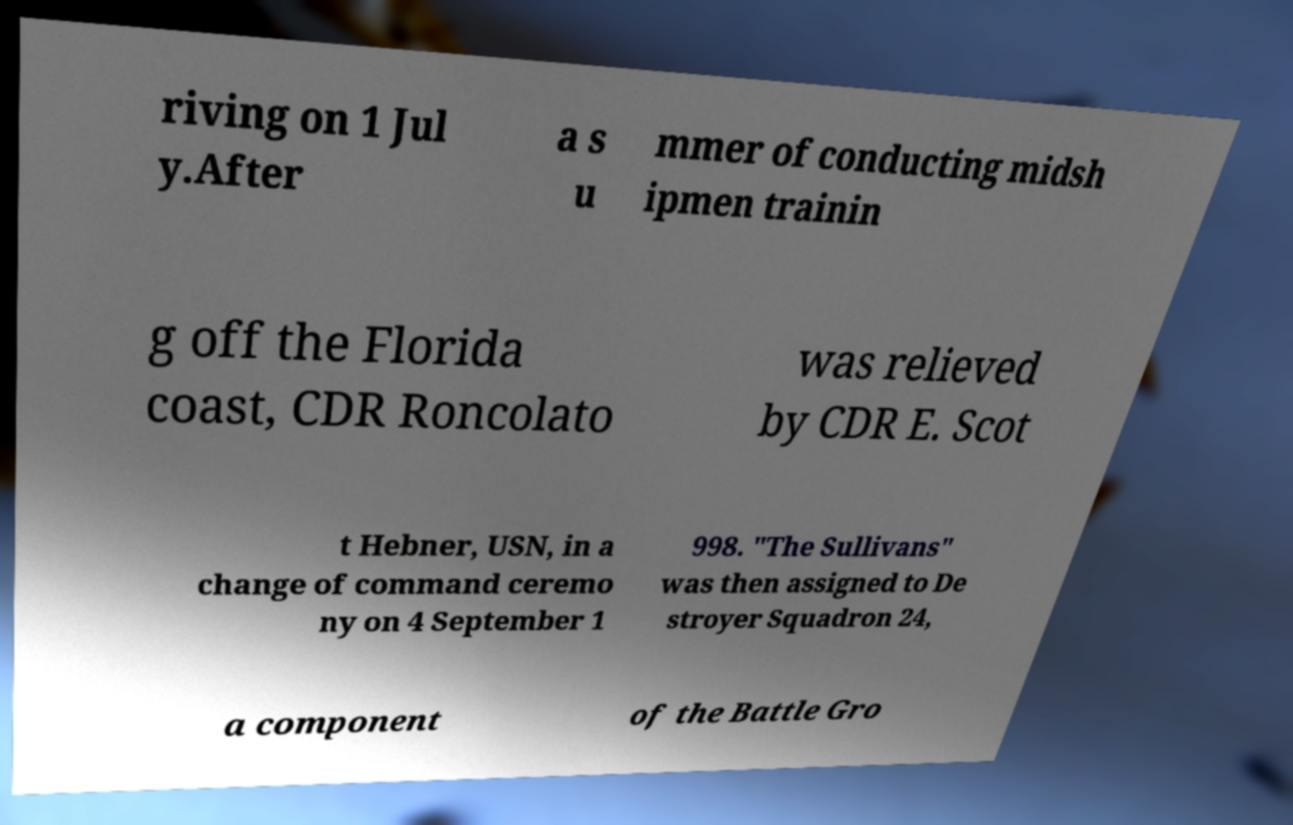Please identify and transcribe the text found in this image. riving on 1 Jul y.After a s u mmer of conducting midsh ipmen trainin g off the Florida coast, CDR Roncolato was relieved by CDR E. Scot t Hebner, USN, in a change of command ceremo ny on 4 September 1 998. "The Sullivans" was then assigned to De stroyer Squadron 24, a component of the Battle Gro 